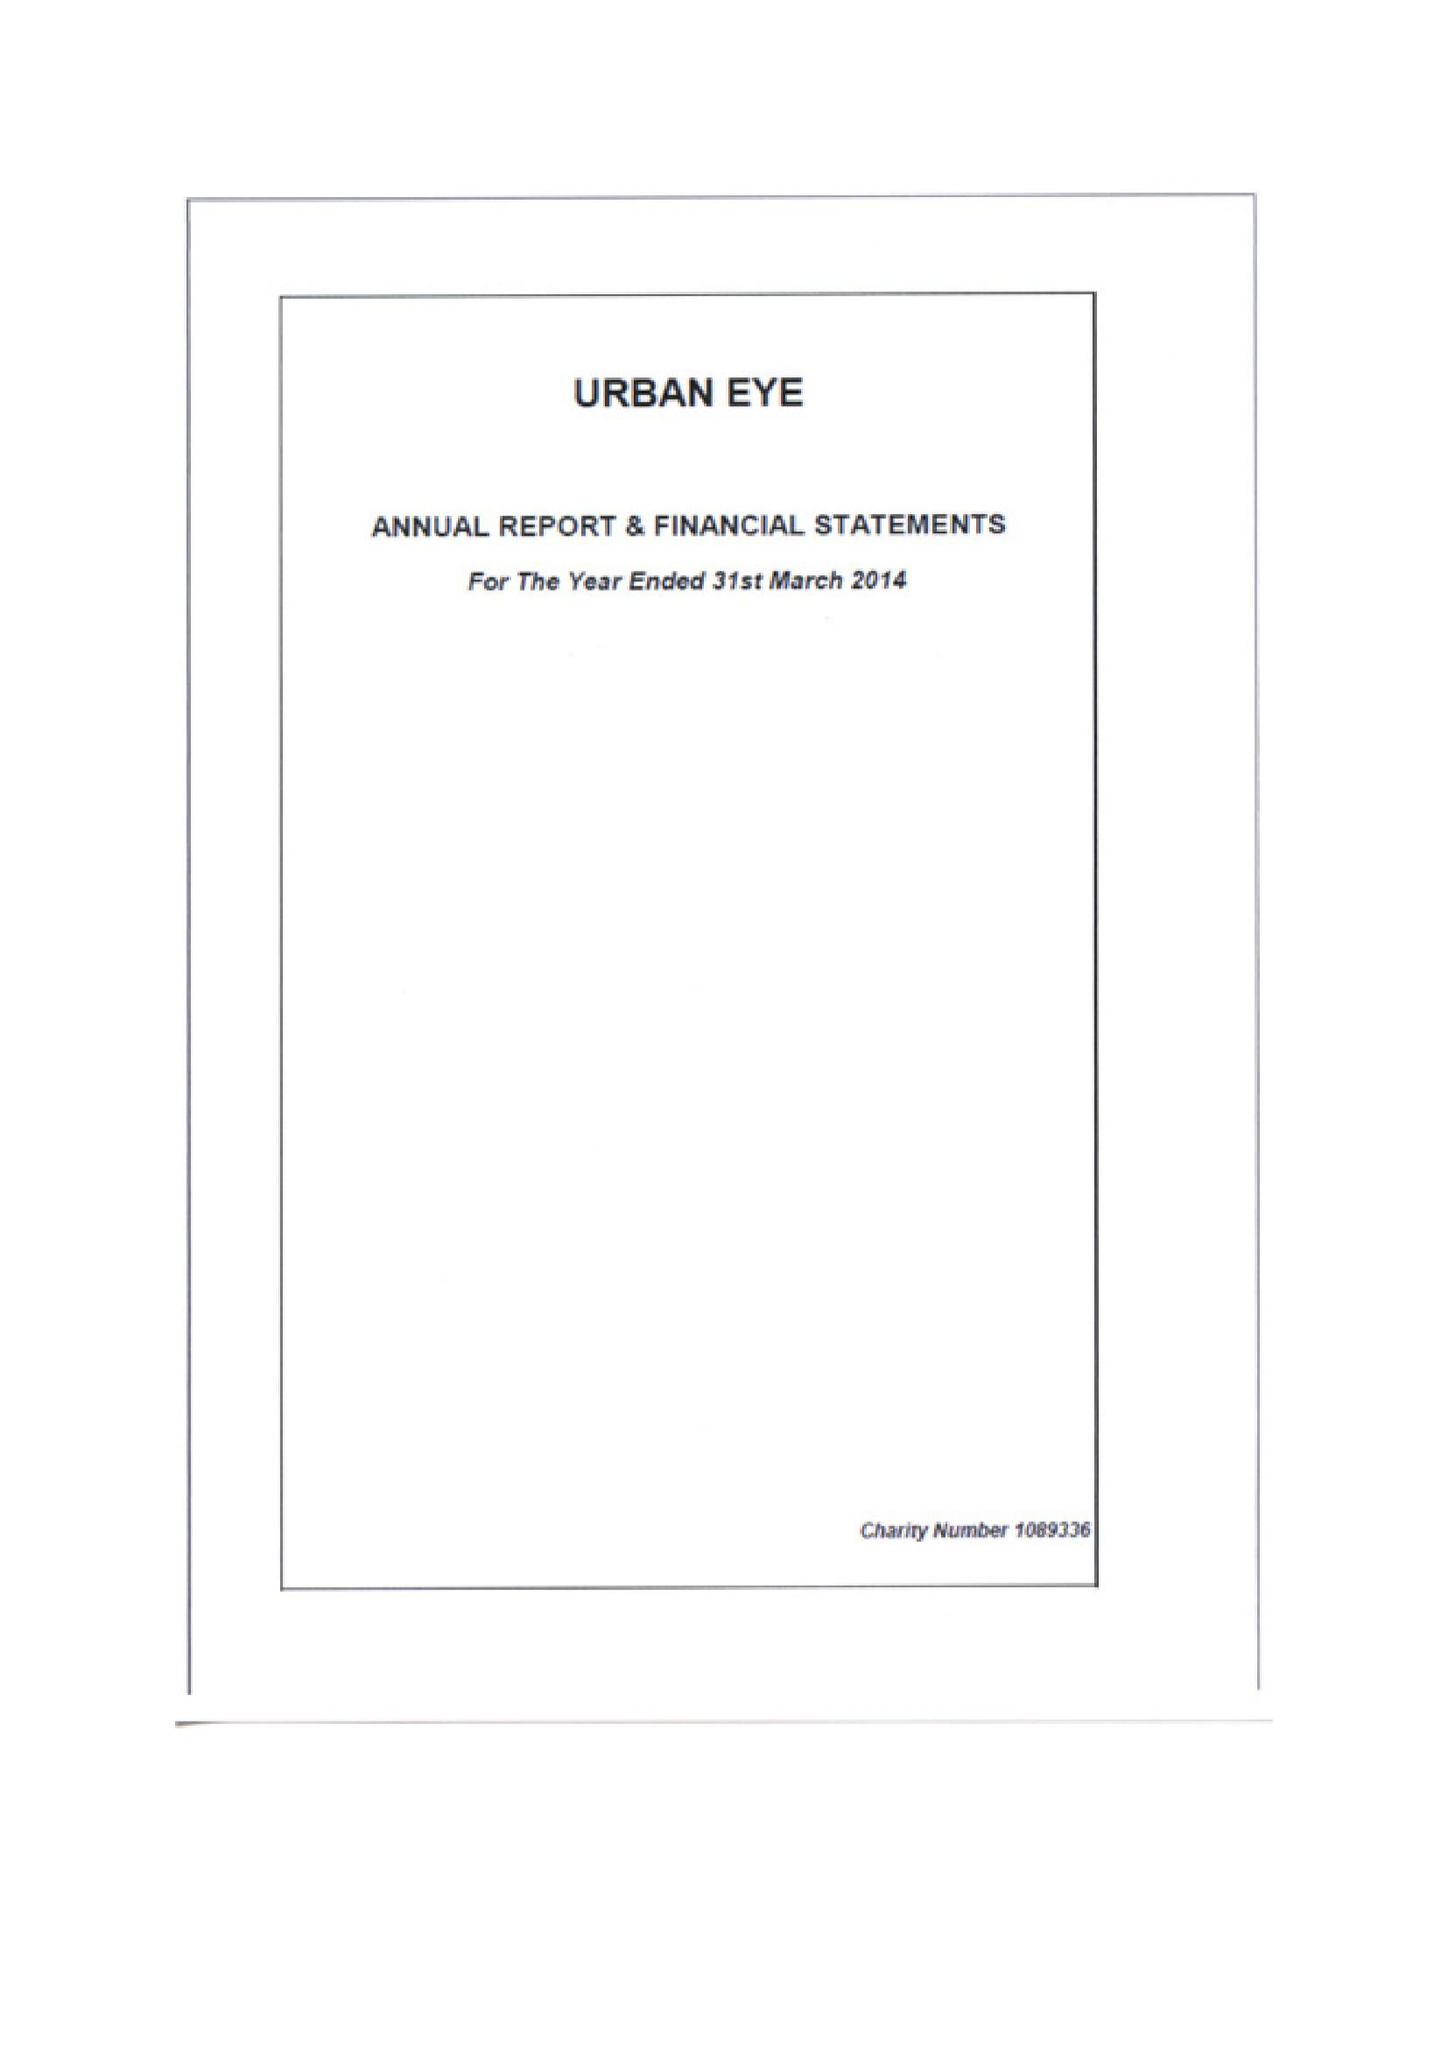What is the value for the income_annually_in_british_pounds?
Answer the question using a single word or phrase. 52863.00 